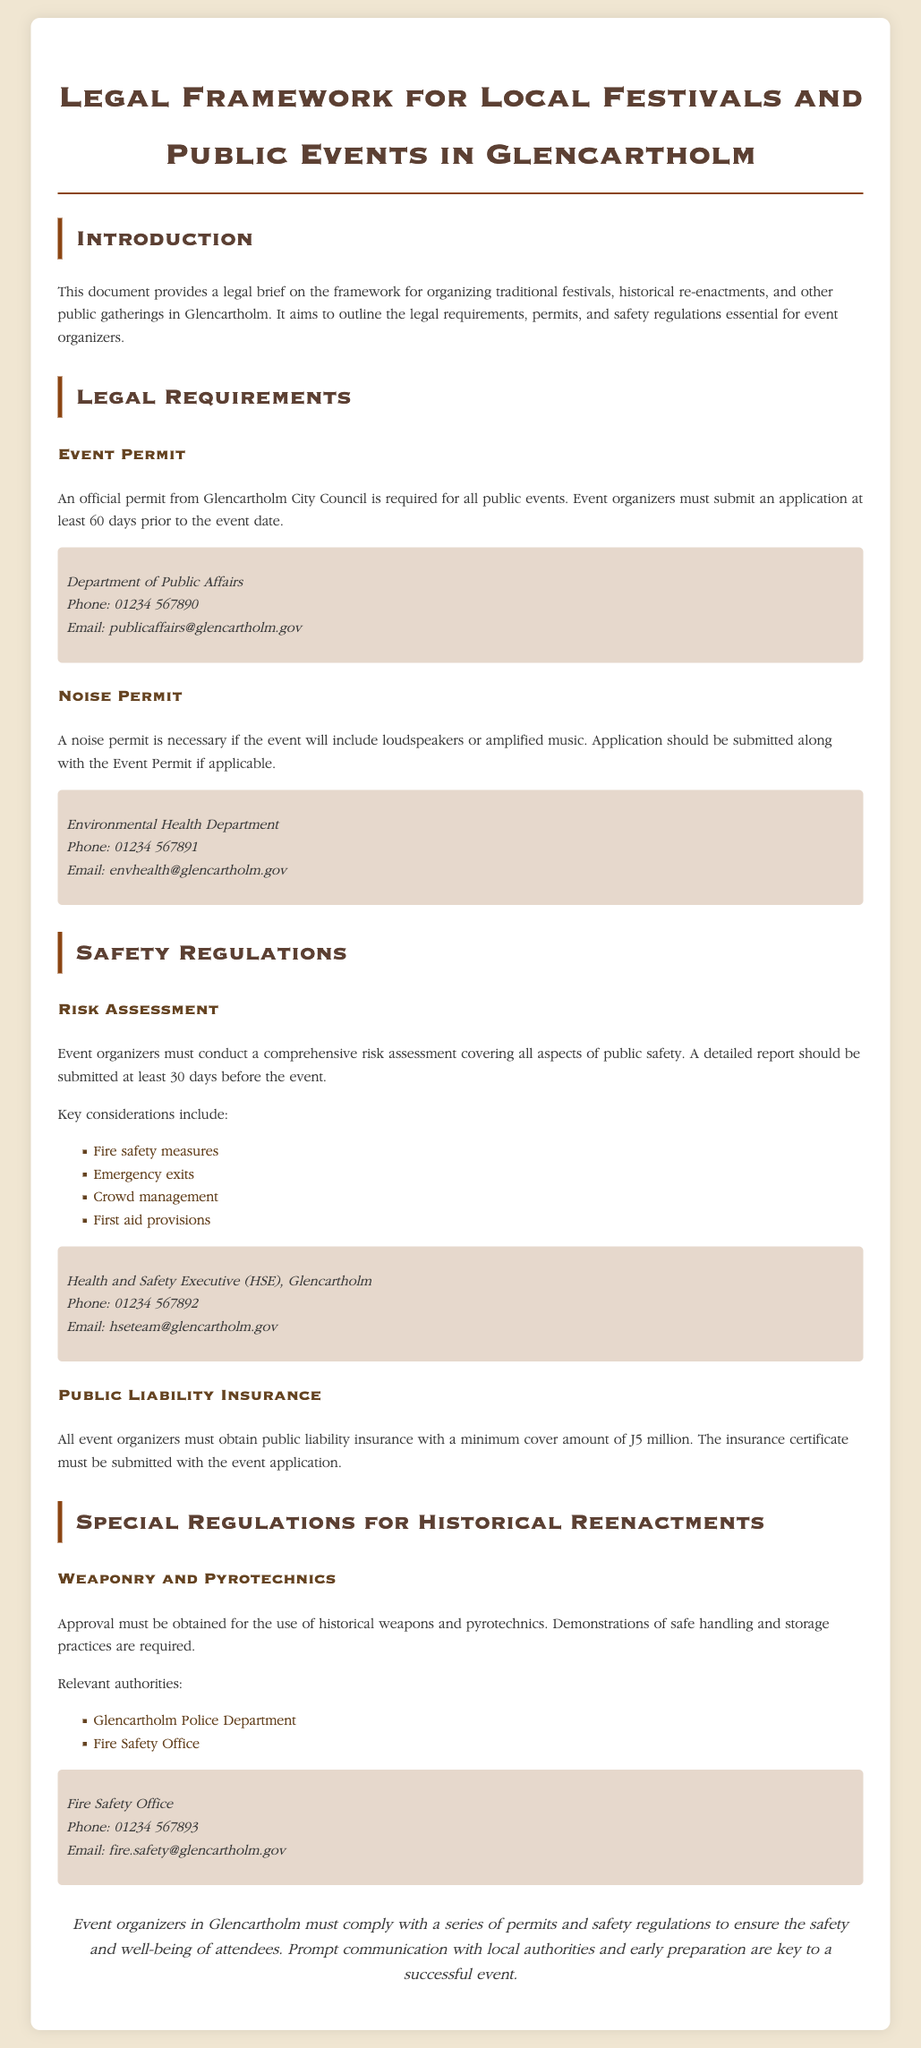What is required for all public events? An official permit from Glencartholm City Council is required for all public events.
Answer: Event Permit How many days before the event must the application be submitted? The event organizers must submit an application at least 60 days prior to the event date.
Answer: 60 days What is the minimum public liability insurance cover amount? All event organizers must obtain public liability insurance with a minimum cover amount of £5 million.
Answer: £5 million Which department should be contacted for noise permits? A noise permit is handled by the Environmental Health Department.
Answer: Environmental Health Department What key consideration must be included in the risk assessment? Key considerations include fire safety measures, emergency exits, crowd management, and first aid provisions.
Answer: Fire safety measures What must be submitted alongside the Event Permit if applicable? A noise permit application should be submitted along with the Event Permit if applicable.
Answer: Noise permit application What is necessary for the use of historical weapons and pyrotechnics? Approval must be obtained for the use of historical weapons and pyrotechnics.
Answer: Approval Who should be contacted regarding safety measures? The Health and Safety Executive (HSE) team in Glencartholm can be contacted regarding safety measures.
Answer: HSE team What is stated in the conclusion about event organizers? The conclusion emphasizes that event organizers must comply with a series of permits and safety regulations.
Answer: Comply with permits and safety regulations 